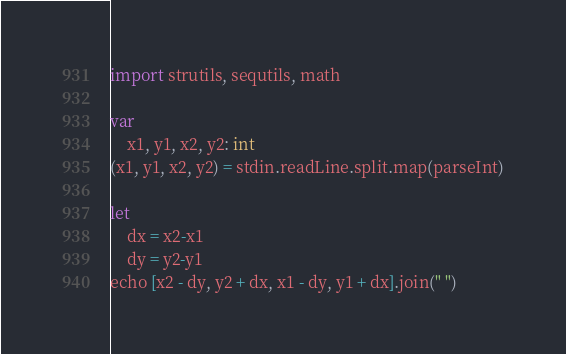Convert code to text. <code><loc_0><loc_0><loc_500><loc_500><_Nim_>import strutils, sequtils, math

var
    x1, y1, x2, y2: int
(x1, y1, x2, y2) = stdin.readLine.split.map(parseInt)

let
    dx = x2-x1
    dy = y2-y1
echo [x2 - dy, y2 + dx, x1 - dy, y1 + dx].join(" ")
</code> 